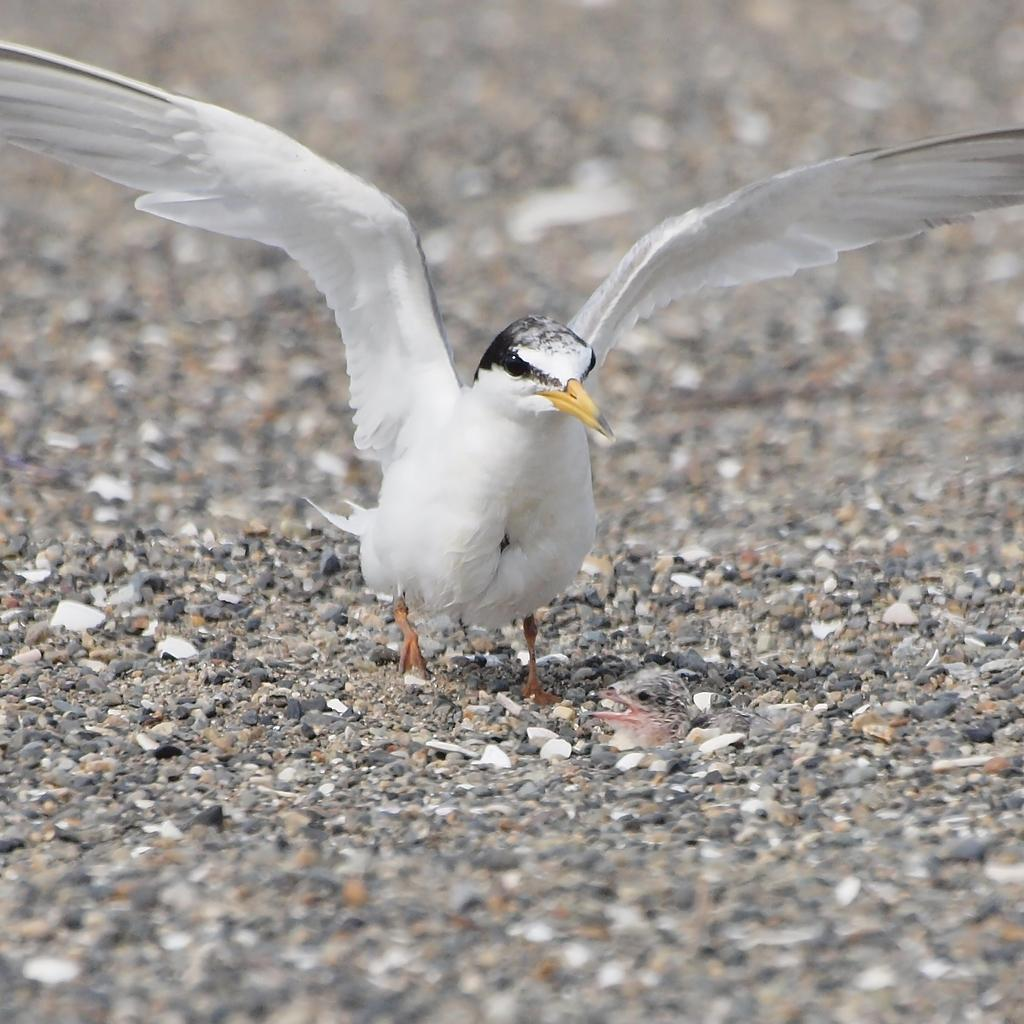What type of animal is present in the image? There is a bird in the image. What is the bird standing on in the image? The bird is on a stone surface. What type of bean can be seen growing on the stone surface in the image? There are no beans present in the image, and the bird is not standing on a plant or any type of bean. 